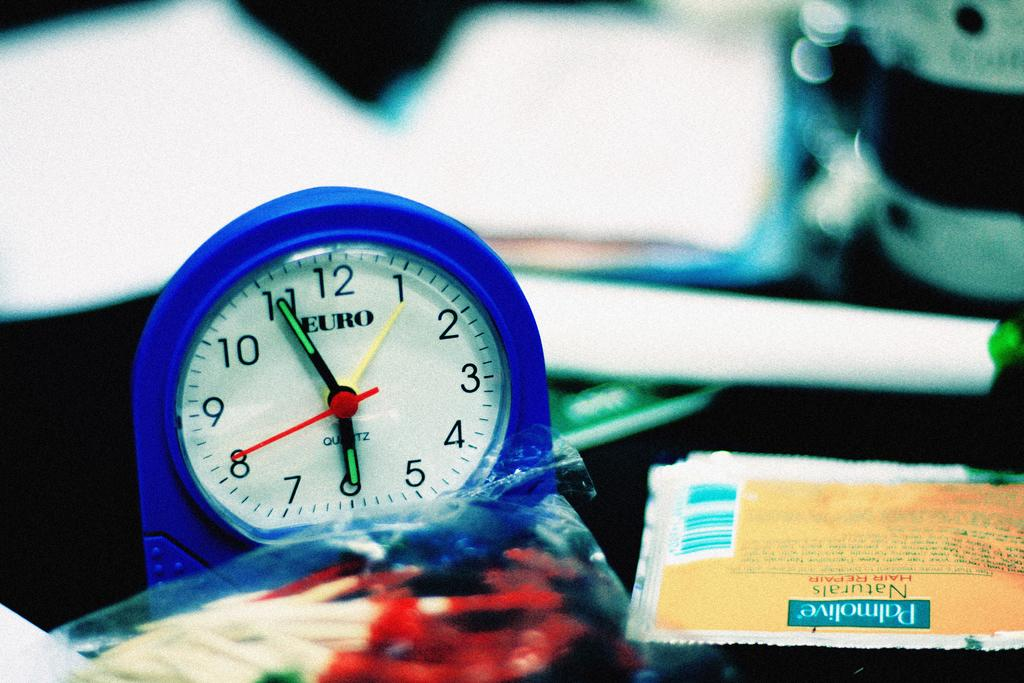<image>
Create a compact narrative representing the image presented. A clock has "EURO" printed on the face. 